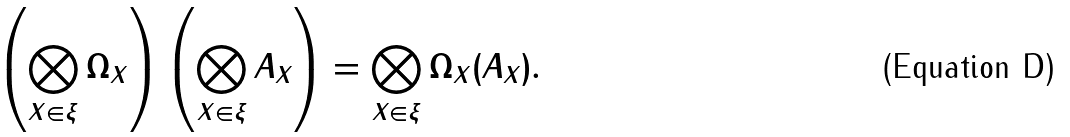<formula> <loc_0><loc_0><loc_500><loc_500>\left ( \bigotimes _ { X \in \xi } \Omega _ { X } \right ) \left ( \bigotimes _ { X \in \xi } A _ { X } \right ) = \bigotimes _ { X \in \xi } \Omega _ { X } ( A _ { X } ) .</formula> 